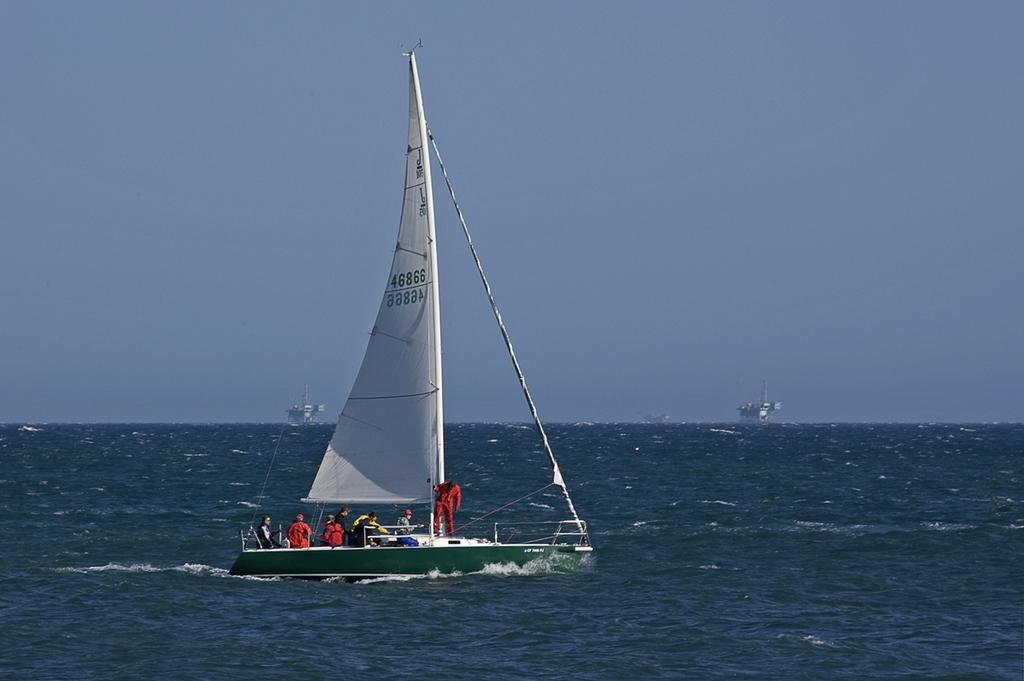What is the main subject of the image? There is a group of people in a sailboat in the image. Where is the sailboat located? The sailboat is in a large water body. What else can be seen in the image besides the sailboat? There are ships visible in the image. What is the condition of the sky in the image? The sky appears cloudy in the image. What type of plants can be seen growing on the sailboat in the image? There are no plants visible on the sailboat in the image. Is there a camera present in the image? There is no camera visible in the image. 